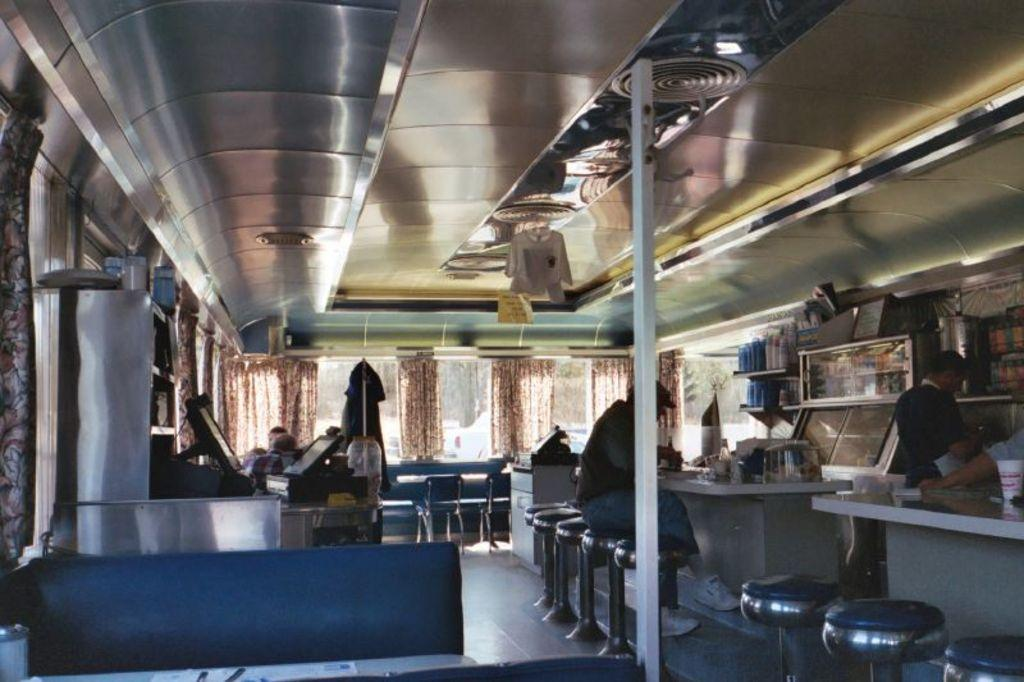What type of establishment is shown in the image? The image depicts a restaurant. Can you describe the people in the restaurant? There are people seated in the restaurant, and there are two people standing in the restaurant. What type of furniture is present in the restaurant? There are chairs in the restaurant, and there is at least one table in the restaurant. Are there any decorative elements in the restaurant? Yes, there are curtains in the restaurant. What type of glass is being used to paste the slip in the image? There is no glass or slip present in the image; it depicts a restaurant with people, chairs, tables, and curtains. 